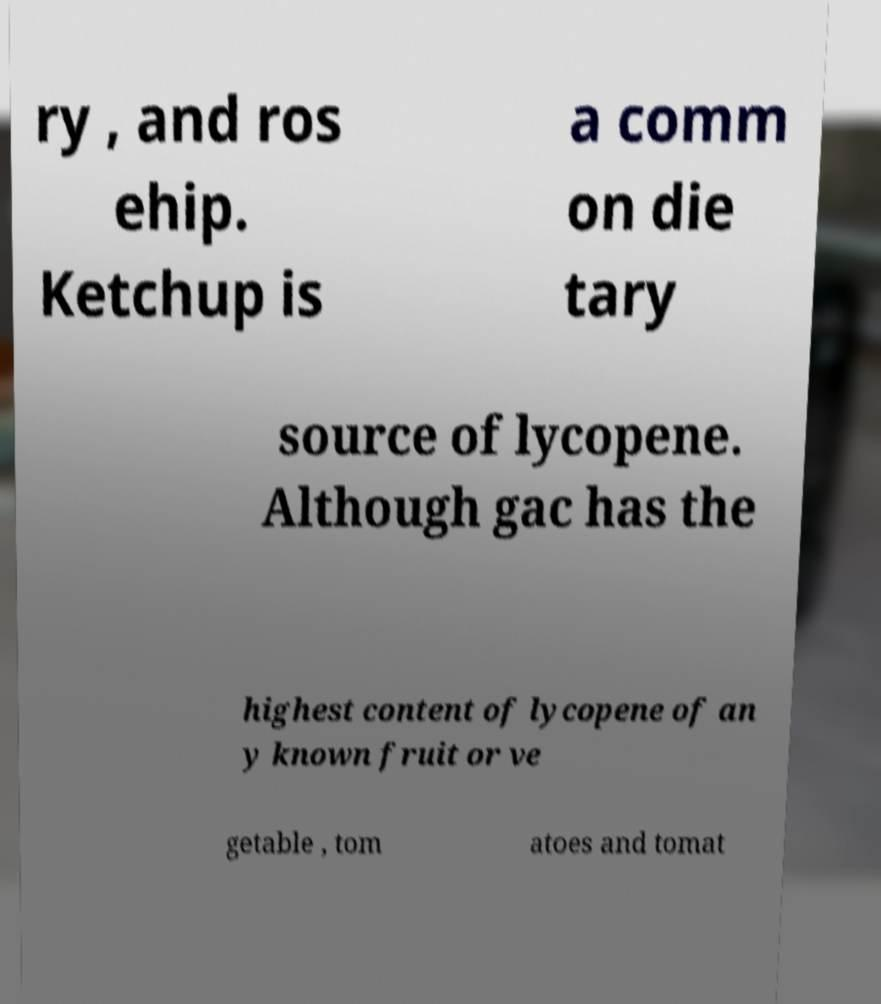Can you accurately transcribe the text from the provided image for me? ry , and ros ehip. Ketchup is a comm on die tary source of lycopene. Although gac has the highest content of lycopene of an y known fruit or ve getable , tom atoes and tomat 